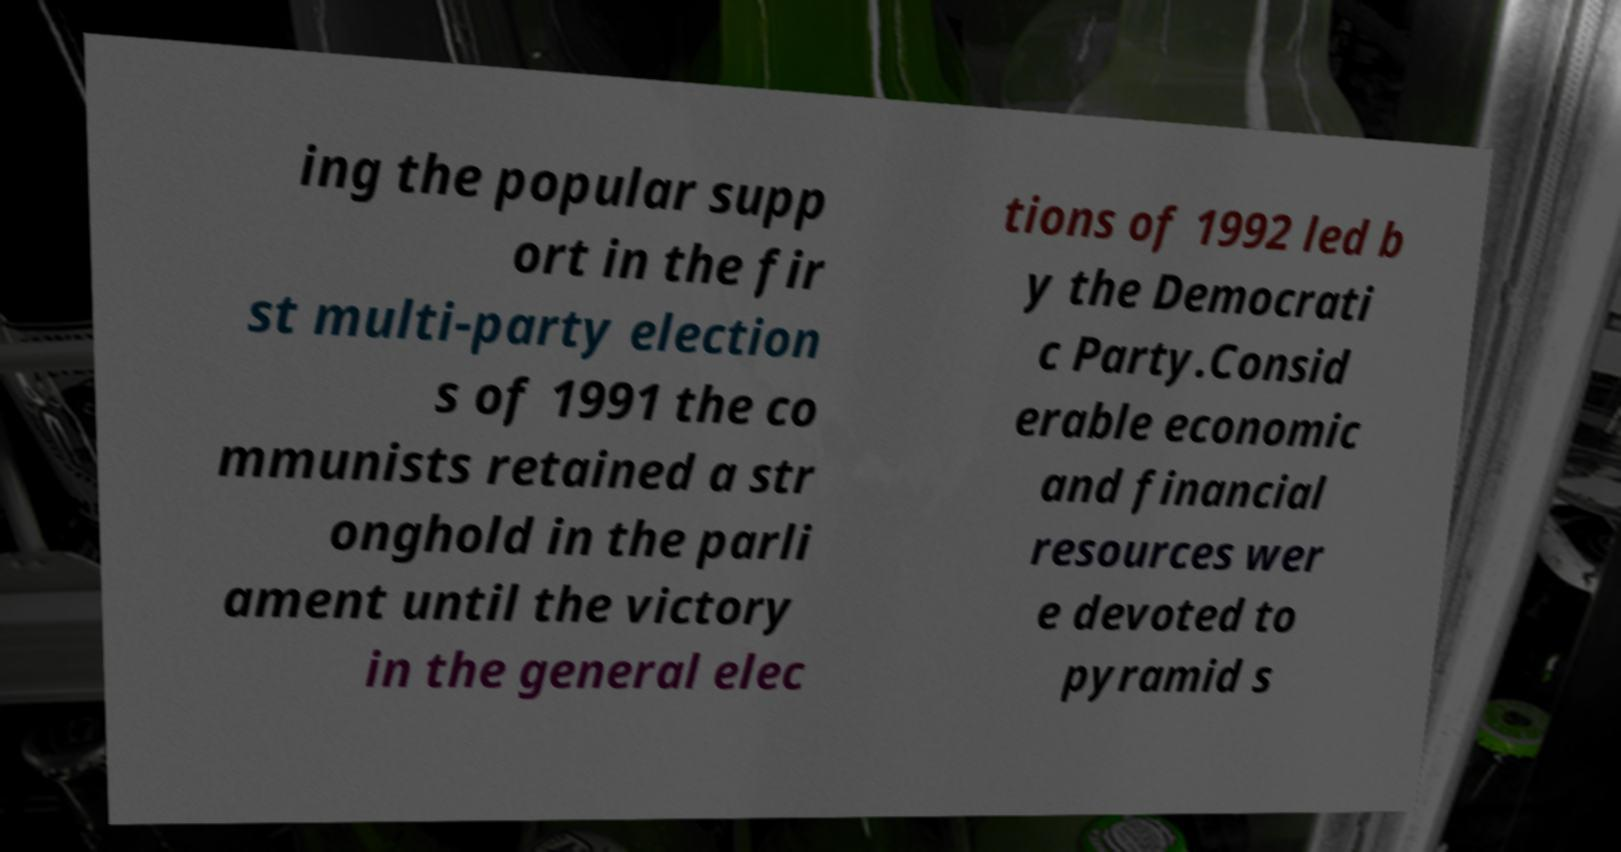Please identify and transcribe the text found in this image. ing the popular supp ort in the fir st multi-party election s of 1991 the co mmunists retained a str onghold in the parli ament until the victory in the general elec tions of 1992 led b y the Democrati c Party.Consid erable economic and financial resources wer e devoted to pyramid s 